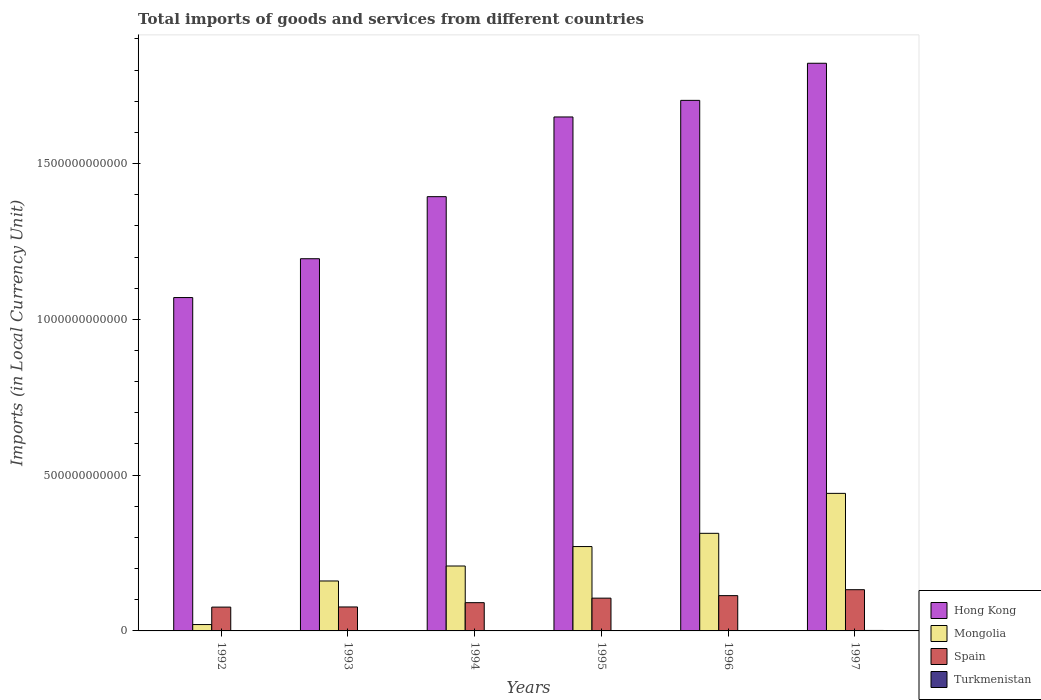How many groups of bars are there?
Offer a very short reply. 6. Are the number of bars per tick equal to the number of legend labels?
Provide a short and direct response. Yes. How many bars are there on the 1st tick from the left?
Give a very brief answer. 4. What is the label of the 4th group of bars from the left?
Offer a very short reply. 1995. In how many cases, is the number of bars for a given year not equal to the number of legend labels?
Your response must be concise. 0. What is the Amount of goods and services imports in Mongolia in 1993?
Your response must be concise. 1.60e+11. Across all years, what is the maximum Amount of goods and services imports in Hong Kong?
Offer a terse response. 1.82e+12. Across all years, what is the minimum Amount of goods and services imports in Mongolia?
Your answer should be very brief. 2.04e+1. In which year was the Amount of goods and services imports in Mongolia maximum?
Offer a terse response. 1997. What is the total Amount of goods and services imports in Spain in the graph?
Make the answer very short. 5.95e+11. What is the difference between the Amount of goods and services imports in Spain in 1993 and that in 1995?
Your answer should be very brief. -2.83e+1. What is the difference between the Amount of goods and services imports in Turkmenistan in 1992 and the Amount of goods and services imports in Spain in 1994?
Make the answer very short. -9.07e+1. What is the average Amount of goods and services imports in Turkmenistan per year?
Your answer should be compact. 4.70e+08. In the year 1995, what is the difference between the Amount of goods and services imports in Mongolia and Amount of goods and services imports in Spain?
Offer a very short reply. 1.66e+11. In how many years, is the Amount of goods and services imports in Turkmenistan greater than 1500000000000 LCU?
Ensure brevity in your answer.  0. What is the ratio of the Amount of goods and services imports in Turkmenistan in 1995 to that in 1996?
Keep it short and to the point. 0.09. What is the difference between the highest and the second highest Amount of goods and services imports in Turkmenistan?
Provide a succinct answer. 3.54e+08. What is the difference between the highest and the lowest Amount of goods and services imports in Mongolia?
Keep it short and to the point. 4.21e+11. In how many years, is the Amount of goods and services imports in Spain greater than the average Amount of goods and services imports in Spain taken over all years?
Your answer should be very brief. 3. What does the 3rd bar from the left in 1995 represents?
Your response must be concise. Spain. What does the 3rd bar from the right in 1994 represents?
Keep it short and to the point. Mongolia. Are all the bars in the graph horizontal?
Provide a short and direct response. No. What is the difference between two consecutive major ticks on the Y-axis?
Your response must be concise. 5.00e+11. Are the values on the major ticks of Y-axis written in scientific E-notation?
Provide a succinct answer. No. How many legend labels are there?
Provide a short and direct response. 4. What is the title of the graph?
Provide a short and direct response. Total imports of goods and services from different countries. Does "Belarus" appear as one of the legend labels in the graph?
Give a very brief answer. No. What is the label or title of the Y-axis?
Your answer should be very brief. Imports (in Local Currency Unit). What is the Imports (in Local Currency Unit) of Hong Kong in 1992?
Provide a short and direct response. 1.07e+12. What is the Imports (in Local Currency Unit) in Mongolia in 1992?
Offer a very short reply. 2.04e+1. What is the Imports (in Local Currency Unit) in Spain in 1992?
Your answer should be very brief. 7.65e+1. What is the Imports (in Local Currency Unit) in Turkmenistan in 1992?
Your answer should be compact. 6.11e+04. What is the Imports (in Local Currency Unit) in Hong Kong in 1993?
Keep it short and to the point. 1.19e+12. What is the Imports (in Local Currency Unit) in Mongolia in 1993?
Make the answer very short. 1.60e+11. What is the Imports (in Local Currency Unit) of Spain in 1993?
Keep it short and to the point. 7.69e+1. What is the Imports (in Local Currency Unit) of Turkmenistan in 1993?
Ensure brevity in your answer.  1.23e+06. What is the Imports (in Local Currency Unit) in Hong Kong in 1994?
Provide a succinct answer. 1.39e+12. What is the Imports (in Local Currency Unit) in Mongolia in 1994?
Offer a terse response. 2.08e+11. What is the Imports (in Local Currency Unit) of Spain in 1994?
Your answer should be very brief. 9.07e+1. What is the Imports (in Local Currency Unit) in Turkmenistan in 1994?
Provide a succinct answer. 1.49e+07. What is the Imports (in Local Currency Unit) in Hong Kong in 1995?
Your answer should be compact. 1.65e+12. What is the Imports (in Local Currency Unit) of Mongolia in 1995?
Make the answer very short. 2.71e+11. What is the Imports (in Local Currency Unit) in Spain in 1995?
Ensure brevity in your answer.  1.05e+11. What is the Imports (in Local Currency Unit) in Turkmenistan in 1995?
Offer a very short reply. 1.10e+08. What is the Imports (in Local Currency Unit) of Hong Kong in 1996?
Offer a terse response. 1.70e+12. What is the Imports (in Local Currency Unit) in Mongolia in 1996?
Keep it short and to the point. 3.13e+11. What is the Imports (in Local Currency Unit) in Spain in 1996?
Your answer should be compact. 1.13e+11. What is the Imports (in Local Currency Unit) in Turkmenistan in 1996?
Your answer should be very brief. 1.17e+09. What is the Imports (in Local Currency Unit) in Hong Kong in 1997?
Your answer should be very brief. 1.82e+12. What is the Imports (in Local Currency Unit) of Mongolia in 1997?
Make the answer very short. 4.42e+11. What is the Imports (in Local Currency Unit) in Spain in 1997?
Your answer should be very brief. 1.32e+11. What is the Imports (in Local Currency Unit) of Turkmenistan in 1997?
Keep it short and to the point. 1.52e+09. Across all years, what is the maximum Imports (in Local Currency Unit) of Hong Kong?
Provide a succinct answer. 1.82e+12. Across all years, what is the maximum Imports (in Local Currency Unit) in Mongolia?
Keep it short and to the point. 4.42e+11. Across all years, what is the maximum Imports (in Local Currency Unit) in Spain?
Your response must be concise. 1.32e+11. Across all years, what is the maximum Imports (in Local Currency Unit) in Turkmenistan?
Provide a succinct answer. 1.52e+09. Across all years, what is the minimum Imports (in Local Currency Unit) in Hong Kong?
Keep it short and to the point. 1.07e+12. Across all years, what is the minimum Imports (in Local Currency Unit) of Mongolia?
Provide a short and direct response. 2.04e+1. Across all years, what is the minimum Imports (in Local Currency Unit) of Spain?
Offer a terse response. 7.65e+1. Across all years, what is the minimum Imports (in Local Currency Unit) of Turkmenistan?
Offer a very short reply. 6.11e+04. What is the total Imports (in Local Currency Unit) of Hong Kong in the graph?
Ensure brevity in your answer.  8.83e+12. What is the total Imports (in Local Currency Unit) of Mongolia in the graph?
Offer a very short reply. 1.41e+12. What is the total Imports (in Local Currency Unit) in Spain in the graph?
Keep it short and to the point. 5.95e+11. What is the total Imports (in Local Currency Unit) in Turkmenistan in the graph?
Offer a very short reply. 2.82e+09. What is the difference between the Imports (in Local Currency Unit) of Hong Kong in 1992 and that in 1993?
Your response must be concise. -1.25e+11. What is the difference between the Imports (in Local Currency Unit) of Mongolia in 1992 and that in 1993?
Keep it short and to the point. -1.40e+11. What is the difference between the Imports (in Local Currency Unit) in Spain in 1992 and that in 1993?
Make the answer very short. -4.49e+08. What is the difference between the Imports (in Local Currency Unit) in Turkmenistan in 1992 and that in 1993?
Offer a very short reply. -1.17e+06. What is the difference between the Imports (in Local Currency Unit) in Hong Kong in 1992 and that in 1994?
Keep it short and to the point. -3.24e+11. What is the difference between the Imports (in Local Currency Unit) in Mongolia in 1992 and that in 1994?
Keep it short and to the point. -1.88e+11. What is the difference between the Imports (in Local Currency Unit) in Spain in 1992 and that in 1994?
Offer a terse response. -1.42e+1. What is the difference between the Imports (in Local Currency Unit) in Turkmenistan in 1992 and that in 1994?
Keep it short and to the point. -1.48e+07. What is the difference between the Imports (in Local Currency Unit) in Hong Kong in 1992 and that in 1995?
Your answer should be very brief. -5.80e+11. What is the difference between the Imports (in Local Currency Unit) of Mongolia in 1992 and that in 1995?
Offer a very short reply. -2.50e+11. What is the difference between the Imports (in Local Currency Unit) in Spain in 1992 and that in 1995?
Offer a very short reply. -2.87e+1. What is the difference between the Imports (in Local Currency Unit) of Turkmenistan in 1992 and that in 1995?
Make the answer very short. -1.10e+08. What is the difference between the Imports (in Local Currency Unit) in Hong Kong in 1992 and that in 1996?
Your answer should be compact. -6.33e+11. What is the difference between the Imports (in Local Currency Unit) of Mongolia in 1992 and that in 1996?
Ensure brevity in your answer.  -2.93e+11. What is the difference between the Imports (in Local Currency Unit) in Spain in 1992 and that in 1996?
Offer a terse response. -3.68e+1. What is the difference between the Imports (in Local Currency Unit) of Turkmenistan in 1992 and that in 1996?
Give a very brief answer. -1.17e+09. What is the difference between the Imports (in Local Currency Unit) in Hong Kong in 1992 and that in 1997?
Provide a succinct answer. -7.52e+11. What is the difference between the Imports (in Local Currency Unit) in Mongolia in 1992 and that in 1997?
Offer a terse response. -4.21e+11. What is the difference between the Imports (in Local Currency Unit) of Spain in 1992 and that in 1997?
Ensure brevity in your answer.  -5.59e+1. What is the difference between the Imports (in Local Currency Unit) in Turkmenistan in 1992 and that in 1997?
Your answer should be very brief. -1.52e+09. What is the difference between the Imports (in Local Currency Unit) of Hong Kong in 1993 and that in 1994?
Your answer should be compact. -1.99e+11. What is the difference between the Imports (in Local Currency Unit) in Mongolia in 1993 and that in 1994?
Your answer should be compact. -4.80e+1. What is the difference between the Imports (in Local Currency Unit) in Spain in 1993 and that in 1994?
Offer a terse response. -1.38e+1. What is the difference between the Imports (in Local Currency Unit) in Turkmenistan in 1993 and that in 1994?
Your response must be concise. -1.36e+07. What is the difference between the Imports (in Local Currency Unit) in Hong Kong in 1993 and that in 1995?
Offer a terse response. -4.55e+11. What is the difference between the Imports (in Local Currency Unit) of Mongolia in 1993 and that in 1995?
Provide a succinct answer. -1.10e+11. What is the difference between the Imports (in Local Currency Unit) of Spain in 1993 and that in 1995?
Keep it short and to the point. -2.83e+1. What is the difference between the Imports (in Local Currency Unit) in Turkmenistan in 1993 and that in 1995?
Your response must be concise. -1.09e+08. What is the difference between the Imports (in Local Currency Unit) in Hong Kong in 1993 and that in 1996?
Offer a very short reply. -5.08e+11. What is the difference between the Imports (in Local Currency Unit) of Mongolia in 1993 and that in 1996?
Provide a short and direct response. -1.53e+11. What is the difference between the Imports (in Local Currency Unit) of Spain in 1993 and that in 1996?
Make the answer very short. -3.64e+1. What is the difference between the Imports (in Local Currency Unit) in Turkmenistan in 1993 and that in 1996?
Your answer should be very brief. -1.17e+09. What is the difference between the Imports (in Local Currency Unit) of Hong Kong in 1993 and that in 1997?
Provide a short and direct response. -6.27e+11. What is the difference between the Imports (in Local Currency Unit) of Mongolia in 1993 and that in 1997?
Make the answer very short. -2.81e+11. What is the difference between the Imports (in Local Currency Unit) of Spain in 1993 and that in 1997?
Offer a terse response. -5.54e+1. What is the difference between the Imports (in Local Currency Unit) of Turkmenistan in 1993 and that in 1997?
Your response must be concise. -1.52e+09. What is the difference between the Imports (in Local Currency Unit) in Hong Kong in 1994 and that in 1995?
Provide a short and direct response. -2.56e+11. What is the difference between the Imports (in Local Currency Unit) in Mongolia in 1994 and that in 1995?
Keep it short and to the point. -6.24e+1. What is the difference between the Imports (in Local Currency Unit) of Spain in 1994 and that in 1995?
Provide a succinct answer. -1.45e+1. What is the difference between the Imports (in Local Currency Unit) of Turkmenistan in 1994 and that in 1995?
Make the answer very short. -9.49e+07. What is the difference between the Imports (in Local Currency Unit) of Hong Kong in 1994 and that in 1996?
Offer a terse response. -3.09e+11. What is the difference between the Imports (in Local Currency Unit) of Mongolia in 1994 and that in 1996?
Your answer should be very brief. -1.05e+11. What is the difference between the Imports (in Local Currency Unit) of Spain in 1994 and that in 1996?
Your answer should be very brief. -2.26e+1. What is the difference between the Imports (in Local Currency Unit) of Turkmenistan in 1994 and that in 1996?
Offer a terse response. -1.15e+09. What is the difference between the Imports (in Local Currency Unit) of Hong Kong in 1994 and that in 1997?
Your response must be concise. -4.28e+11. What is the difference between the Imports (in Local Currency Unit) of Mongolia in 1994 and that in 1997?
Your answer should be compact. -2.33e+11. What is the difference between the Imports (in Local Currency Unit) in Spain in 1994 and that in 1997?
Your answer should be compact. -4.16e+1. What is the difference between the Imports (in Local Currency Unit) of Turkmenistan in 1994 and that in 1997?
Ensure brevity in your answer.  -1.51e+09. What is the difference between the Imports (in Local Currency Unit) in Hong Kong in 1995 and that in 1996?
Keep it short and to the point. -5.33e+1. What is the difference between the Imports (in Local Currency Unit) of Mongolia in 1995 and that in 1996?
Offer a very short reply. -4.25e+1. What is the difference between the Imports (in Local Currency Unit) of Spain in 1995 and that in 1996?
Keep it short and to the point. -8.08e+09. What is the difference between the Imports (in Local Currency Unit) of Turkmenistan in 1995 and that in 1996?
Ensure brevity in your answer.  -1.06e+09. What is the difference between the Imports (in Local Currency Unit) in Hong Kong in 1995 and that in 1997?
Ensure brevity in your answer.  -1.72e+11. What is the difference between the Imports (in Local Currency Unit) of Mongolia in 1995 and that in 1997?
Offer a terse response. -1.71e+11. What is the difference between the Imports (in Local Currency Unit) of Spain in 1995 and that in 1997?
Provide a succinct answer. -2.71e+1. What is the difference between the Imports (in Local Currency Unit) of Turkmenistan in 1995 and that in 1997?
Provide a short and direct response. -1.41e+09. What is the difference between the Imports (in Local Currency Unit) in Hong Kong in 1996 and that in 1997?
Ensure brevity in your answer.  -1.19e+11. What is the difference between the Imports (in Local Currency Unit) of Mongolia in 1996 and that in 1997?
Ensure brevity in your answer.  -1.28e+11. What is the difference between the Imports (in Local Currency Unit) of Spain in 1996 and that in 1997?
Your answer should be very brief. -1.90e+1. What is the difference between the Imports (in Local Currency Unit) in Turkmenistan in 1996 and that in 1997?
Make the answer very short. -3.54e+08. What is the difference between the Imports (in Local Currency Unit) of Hong Kong in 1992 and the Imports (in Local Currency Unit) of Mongolia in 1993?
Keep it short and to the point. 9.10e+11. What is the difference between the Imports (in Local Currency Unit) of Hong Kong in 1992 and the Imports (in Local Currency Unit) of Spain in 1993?
Your answer should be compact. 9.93e+11. What is the difference between the Imports (in Local Currency Unit) of Hong Kong in 1992 and the Imports (in Local Currency Unit) of Turkmenistan in 1993?
Your answer should be compact. 1.07e+12. What is the difference between the Imports (in Local Currency Unit) of Mongolia in 1992 and the Imports (in Local Currency Unit) of Spain in 1993?
Make the answer very short. -5.65e+1. What is the difference between the Imports (in Local Currency Unit) in Mongolia in 1992 and the Imports (in Local Currency Unit) in Turkmenistan in 1993?
Keep it short and to the point. 2.04e+1. What is the difference between the Imports (in Local Currency Unit) of Spain in 1992 and the Imports (in Local Currency Unit) of Turkmenistan in 1993?
Your answer should be compact. 7.65e+1. What is the difference between the Imports (in Local Currency Unit) in Hong Kong in 1992 and the Imports (in Local Currency Unit) in Mongolia in 1994?
Offer a very short reply. 8.62e+11. What is the difference between the Imports (in Local Currency Unit) of Hong Kong in 1992 and the Imports (in Local Currency Unit) of Spain in 1994?
Provide a short and direct response. 9.79e+11. What is the difference between the Imports (in Local Currency Unit) in Hong Kong in 1992 and the Imports (in Local Currency Unit) in Turkmenistan in 1994?
Your answer should be compact. 1.07e+12. What is the difference between the Imports (in Local Currency Unit) of Mongolia in 1992 and the Imports (in Local Currency Unit) of Spain in 1994?
Your answer should be very brief. -7.03e+1. What is the difference between the Imports (in Local Currency Unit) of Mongolia in 1992 and the Imports (in Local Currency Unit) of Turkmenistan in 1994?
Your answer should be compact. 2.04e+1. What is the difference between the Imports (in Local Currency Unit) in Spain in 1992 and the Imports (in Local Currency Unit) in Turkmenistan in 1994?
Give a very brief answer. 7.64e+1. What is the difference between the Imports (in Local Currency Unit) of Hong Kong in 1992 and the Imports (in Local Currency Unit) of Mongolia in 1995?
Offer a terse response. 7.99e+11. What is the difference between the Imports (in Local Currency Unit) in Hong Kong in 1992 and the Imports (in Local Currency Unit) in Spain in 1995?
Provide a short and direct response. 9.65e+11. What is the difference between the Imports (in Local Currency Unit) of Hong Kong in 1992 and the Imports (in Local Currency Unit) of Turkmenistan in 1995?
Your response must be concise. 1.07e+12. What is the difference between the Imports (in Local Currency Unit) in Mongolia in 1992 and the Imports (in Local Currency Unit) in Spain in 1995?
Your answer should be compact. -8.48e+1. What is the difference between the Imports (in Local Currency Unit) of Mongolia in 1992 and the Imports (in Local Currency Unit) of Turkmenistan in 1995?
Your response must be concise. 2.03e+1. What is the difference between the Imports (in Local Currency Unit) in Spain in 1992 and the Imports (in Local Currency Unit) in Turkmenistan in 1995?
Offer a terse response. 7.63e+1. What is the difference between the Imports (in Local Currency Unit) of Hong Kong in 1992 and the Imports (in Local Currency Unit) of Mongolia in 1996?
Ensure brevity in your answer.  7.57e+11. What is the difference between the Imports (in Local Currency Unit) in Hong Kong in 1992 and the Imports (in Local Currency Unit) in Spain in 1996?
Ensure brevity in your answer.  9.57e+11. What is the difference between the Imports (in Local Currency Unit) in Hong Kong in 1992 and the Imports (in Local Currency Unit) in Turkmenistan in 1996?
Your response must be concise. 1.07e+12. What is the difference between the Imports (in Local Currency Unit) in Mongolia in 1992 and the Imports (in Local Currency Unit) in Spain in 1996?
Keep it short and to the point. -9.29e+1. What is the difference between the Imports (in Local Currency Unit) of Mongolia in 1992 and the Imports (in Local Currency Unit) of Turkmenistan in 1996?
Offer a terse response. 1.92e+1. What is the difference between the Imports (in Local Currency Unit) of Spain in 1992 and the Imports (in Local Currency Unit) of Turkmenistan in 1996?
Give a very brief answer. 7.53e+1. What is the difference between the Imports (in Local Currency Unit) in Hong Kong in 1992 and the Imports (in Local Currency Unit) in Mongolia in 1997?
Your response must be concise. 6.28e+11. What is the difference between the Imports (in Local Currency Unit) in Hong Kong in 1992 and the Imports (in Local Currency Unit) in Spain in 1997?
Offer a very short reply. 9.38e+11. What is the difference between the Imports (in Local Currency Unit) in Hong Kong in 1992 and the Imports (in Local Currency Unit) in Turkmenistan in 1997?
Make the answer very short. 1.07e+12. What is the difference between the Imports (in Local Currency Unit) in Mongolia in 1992 and the Imports (in Local Currency Unit) in Spain in 1997?
Provide a short and direct response. -1.12e+11. What is the difference between the Imports (in Local Currency Unit) of Mongolia in 1992 and the Imports (in Local Currency Unit) of Turkmenistan in 1997?
Provide a short and direct response. 1.89e+1. What is the difference between the Imports (in Local Currency Unit) in Spain in 1992 and the Imports (in Local Currency Unit) in Turkmenistan in 1997?
Provide a short and direct response. 7.49e+1. What is the difference between the Imports (in Local Currency Unit) in Hong Kong in 1993 and the Imports (in Local Currency Unit) in Mongolia in 1994?
Ensure brevity in your answer.  9.86e+11. What is the difference between the Imports (in Local Currency Unit) of Hong Kong in 1993 and the Imports (in Local Currency Unit) of Spain in 1994?
Keep it short and to the point. 1.10e+12. What is the difference between the Imports (in Local Currency Unit) in Hong Kong in 1993 and the Imports (in Local Currency Unit) in Turkmenistan in 1994?
Your response must be concise. 1.19e+12. What is the difference between the Imports (in Local Currency Unit) in Mongolia in 1993 and the Imports (in Local Currency Unit) in Spain in 1994?
Make the answer very short. 6.96e+1. What is the difference between the Imports (in Local Currency Unit) in Mongolia in 1993 and the Imports (in Local Currency Unit) in Turkmenistan in 1994?
Keep it short and to the point. 1.60e+11. What is the difference between the Imports (in Local Currency Unit) in Spain in 1993 and the Imports (in Local Currency Unit) in Turkmenistan in 1994?
Provide a succinct answer. 7.69e+1. What is the difference between the Imports (in Local Currency Unit) of Hong Kong in 1993 and the Imports (in Local Currency Unit) of Mongolia in 1995?
Make the answer very short. 9.24e+11. What is the difference between the Imports (in Local Currency Unit) of Hong Kong in 1993 and the Imports (in Local Currency Unit) of Spain in 1995?
Make the answer very short. 1.09e+12. What is the difference between the Imports (in Local Currency Unit) in Hong Kong in 1993 and the Imports (in Local Currency Unit) in Turkmenistan in 1995?
Your response must be concise. 1.19e+12. What is the difference between the Imports (in Local Currency Unit) in Mongolia in 1993 and the Imports (in Local Currency Unit) in Spain in 1995?
Provide a short and direct response. 5.51e+1. What is the difference between the Imports (in Local Currency Unit) of Mongolia in 1993 and the Imports (in Local Currency Unit) of Turkmenistan in 1995?
Provide a short and direct response. 1.60e+11. What is the difference between the Imports (in Local Currency Unit) of Spain in 1993 and the Imports (in Local Currency Unit) of Turkmenistan in 1995?
Ensure brevity in your answer.  7.68e+1. What is the difference between the Imports (in Local Currency Unit) of Hong Kong in 1993 and the Imports (in Local Currency Unit) of Mongolia in 1996?
Provide a succinct answer. 8.81e+11. What is the difference between the Imports (in Local Currency Unit) of Hong Kong in 1993 and the Imports (in Local Currency Unit) of Spain in 1996?
Your answer should be very brief. 1.08e+12. What is the difference between the Imports (in Local Currency Unit) of Hong Kong in 1993 and the Imports (in Local Currency Unit) of Turkmenistan in 1996?
Offer a very short reply. 1.19e+12. What is the difference between the Imports (in Local Currency Unit) of Mongolia in 1993 and the Imports (in Local Currency Unit) of Spain in 1996?
Provide a short and direct response. 4.70e+1. What is the difference between the Imports (in Local Currency Unit) in Mongolia in 1993 and the Imports (in Local Currency Unit) in Turkmenistan in 1996?
Your response must be concise. 1.59e+11. What is the difference between the Imports (in Local Currency Unit) in Spain in 1993 and the Imports (in Local Currency Unit) in Turkmenistan in 1996?
Your answer should be very brief. 7.57e+1. What is the difference between the Imports (in Local Currency Unit) in Hong Kong in 1993 and the Imports (in Local Currency Unit) in Mongolia in 1997?
Ensure brevity in your answer.  7.53e+11. What is the difference between the Imports (in Local Currency Unit) of Hong Kong in 1993 and the Imports (in Local Currency Unit) of Spain in 1997?
Your answer should be compact. 1.06e+12. What is the difference between the Imports (in Local Currency Unit) in Hong Kong in 1993 and the Imports (in Local Currency Unit) in Turkmenistan in 1997?
Provide a succinct answer. 1.19e+12. What is the difference between the Imports (in Local Currency Unit) in Mongolia in 1993 and the Imports (in Local Currency Unit) in Spain in 1997?
Your response must be concise. 2.80e+1. What is the difference between the Imports (in Local Currency Unit) in Mongolia in 1993 and the Imports (in Local Currency Unit) in Turkmenistan in 1997?
Provide a succinct answer. 1.59e+11. What is the difference between the Imports (in Local Currency Unit) of Spain in 1993 and the Imports (in Local Currency Unit) of Turkmenistan in 1997?
Your answer should be compact. 7.54e+1. What is the difference between the Imports (in Local Currency Unit) in Hong Kong in 1994 and the Imports (in Local Currency Unit) in Mongolia in 1995?
Your answer should be very brief. 1.12e+12. What is the difference between the Imports (in Local Currency Unit) of Hong Kong in 1994 and the Imports (in Local Currency Unit) of Spain in 1995?
Your response must be concise. 1.29e+12. What is the difference between the Imports (in Local Currency Unit) of Hong Kong in 1994 and the Imports (in Local Currency Unit) of Turkmenistan in 1995?
Your response must be concise. 1.39e+12. What is the difference between the Imports (in Local Currency Unit) in Mongolia in 1994 and the Imports (in Local Currency Unit) in Spain in 1995?
Ensure brevity in your answer.  1.03e+11. What is the difference between the Imports (in Local Currency Unit) of Mongolia in 1994 and the Imports (in Local Currency Unit) of Turkmenistan in 1995?
Ensure brevity in your answer.  2.08e+11. What is the difference between the Imports (in Local Currency Unit) of Spain in 1994 and the Imports (in Local Currency Unit) of Turkmenistan in 1995?
Your answer should be very brief. 9.06e+1. What is the difference between the Imports (in Local Currency Unit) of Hong Kong in 1994 and the Imports (in Local Currency Unit) of Mongolia in 1996?
Offer a very short reply. 1.08e+12. What is the difference between the Imports (in Local Currency Unit) of Hong Kong in 1994 and the Imports (in Local Currency Unit) of Spain in 1996?
Your response must be concise. 1.28e+12. What is the difference between the Imports (in Local Currency Unit) of Hong Kong in 1994 and the Imports (in Local Currency Unit) of Turkmenistan in 1996?
Keep it short and to the point. 1.39e+12. What is the difference between the Imports (in Local Currency Unit) of Mongolia in 1994 and the Imports (in Local Currency Unit) of Spain in 1996?
Offer a terse response. 9.51e+1. What is the difference between the Imports (in Local Currency Unit) in Mongolia in 1994 and the Imports (in Local Currency Unit) in Turkmenistan in 1996?
Your answer should be very brief. 2.07e+11. What is the difference between the Imports (in Local Currency Unit) in Spain in 1994 and the Imports (in Local Currency Unit) in Turkmenistan in 1996?
Make the answer very short. 8.95e+1. What is the difference between the Imports (in Local Currency Unit) in Hong Kong in 1994 and the Imports (in Local Currency Unit) in Mongolia in 1997?
Keep it short and to the point. 9.52e+11. What is the difference between the Imports (in Local Currency Unit) of Hong Kong in 1994 and the Imports (in Local Currency Unit) of Spain in 1997?
Make the answer very short. 1.26e+12. What is the difference between the Imports (in Local Currency Unit) of Hong Kong in 1994 and the Imports (in Local Currency Unit) of Turkmenistan in 1997?
Provide a short and direct response. 1.39e+12. What is the difference between the Imports (in Local Currency Unit) in Mongolia in 1994 and the Imports (in Local Currency Unit) in Spain in 1997?
Provide a short and direct response. 7.60e+1. What is the difference between the Imports (in Local Currency Unit) of Mongolia in 1994 and the Imports (in Local Currency Unit) of Turkmenistan in 1997?
Your answer should be compact. 2.07e+11. What is the difference between the Imports (in Local Currency Unit) of Spain in 1994 and the Imports (in Local Currency Unit) of Turkmenistan in 1997?
Provide a succinct answer. 8.92e+1. What is the difference between the Imports (in Local Currency Unit) of Hong Kong in 1995 and the Imports (in Local Currency Unit) of Mongolia in 1996?
Provide a short and direct response. 1.34e+12. What is the difference between the Imports (in Local Currency Unit) of Hong Kong in 1995 and the Imports (in Local Currency Unit) of Spain in 1996?
Your answer should be very brief. 1.54e+12. What is the difference between the Imports (in Local Currency Unit) in Hong Kong in 1995 and the Imports (in Local Currency Unit) in Turkmenistan in 1996?
Keep it short and to the point. 1.65e+12. What is the difference between the Imports (in Local Currency Unit) of Mongolia in 1995 and the Imports (in Local Currency Unit) of Spain in 1996?
Keep it short and to the point. 1.57e+11. What is the difference between the Imports (in Local Currency Unit) in Mongolia in 1995 and the Imports (in Local Currency Unit) in Turkmenistan in 1996?
Your response must be concise. 2.70e+11. What is the difference between the Imports (in Local Currency Unit) in Spain in 1995 and the Imports (in Local Currency Unit) in Turkmenistan in 1996?
Offer a terse response. 1.04e+11. What is the difference between the Imports (in Local Currency Unit) in Hong Kong in 1995 and the Imports (in Local Currency Unit) in Mongolia in 1997?
Offer a terse response. 1.21e+12. What is the difference between the Imports (in Local Currency Unit) in Hong Kong in 1995 and the Imports (in Local Currency Unit) in Spain in 1997?
Provide a short and direct response. 1.52e+12. What is the difference between the Imports (in Local Currency Unit) of Hong Kong in 1995 and the Imports (in Local Currency Unit) of Turkmenistan in 1997?
Your answer should be very brief. 1.65e+12. What is the difference between the Imports (in Local Currency Unit) in Mongolia in 1995 and the Imports (in Local Currency Unit) in Spain in 1997?
Give a very brief answer. 1.38e+11. What is the difference between the Imports (in Local Currency Unit) in Mongolia in 1995 and the Imports (in Local Currency Unit) in Turkmenistan in 1997?
Your response must be concise. 2.69e+11. What is the difference between the Imports (in Local Currency Unit) of Spain in 1995 and the Imports (in Local Currency Unit) of Turkmenistan in 1997?
Offer a terse response. 1.04e+11. What is the difference between the Imports (in Local Currency Unit) in Hong Kong in 1996 and the Imports (in Local Currency Unit) in Mongolia in 1997?
Offer a very short reply. 1.26e+12. What is the difference between the Imports (in Local Currency Unit) in Hong Kong in 1996 and the Imports (in Local Currency Unit) in Spain in 1997?
Offer a very short reply. 1.57e+12. What is the difference between the Imports (in Local Currency Unit) of Hong Kong in 1996 and the Imports (in Local Currency Unit) of Turkmenistan in 1997?
Provide a short and direct response. 1.70e+12. What is the difference between the Imports (in Local Currency Unit) in Mongolia in 1996 and the Imports (in Local Currency Unit) in Spain in 1997?
Give a very brief answer. 1.81e+11. What is the difference between the Imports (in Local Currency Unit) of Mongolia in 1996 and the Imports (in Local Currency Unit) of Turkmenistan in 1997?
Offer a very short reply. 3.12e+11. What is the difference between the Imports (in Local Currency Unit) in Spain in 1996 and the Imports (in Local Currency Unit) in Turkmenistan in 1997?
Give a very brief answer. 1.12e+11. What is the average Imports (in Local Currency Unit) in Hong Kong per year?
Your response must be concise. 1.47e+12. What is the average Imports (in Local Currency Unit) of Mongolia per year?
Give a very brief answer. 2.36e+11. What is the average Imports (in Local Currency Unit) in Spain per year?
Provide a succinct answer. 9.91e+1. What is the average Imports (in Local Currency Unit) in Turkmenistan per year?
Give a very brief answer. 4.70e+08. In the year 1992, what is the difference between the Imports (in Local Currency Unit) of Hong Kong and Imports (in Local Currency Unit) of Mongolia?
Offer a very short reply. 1.05e+12. In the year 1992, what is the difference between the Imports (in Local Currency Unit) in Hong Kong and Imports (in Local Currency Unit) in Spain?
Ensure brevity in your answer.  9.93e+11. In the year 1992, what is the difference between the Imports (in Local Currency Unit) in Hong Kong and Imports (in Local Currency Unit) in Turkmenistan?
Your answer should be very brief. 1.07e+12. In the year 1992, what is the difference between the Imports (in Local Currency Unit) of Mongolia and Imports (in Local Currency Unit) of Spain?
Keep it short and to the point. -5.60e+1. In the year 1992, what is the difference between the Imports (in Local Currency Unit) in Mongolia and Imports (in Local Currency Unit) in Turkmenistan?
Your answer should be compact. 2.04e+1. In the year 1992, what is the difference between the Imports (in Local Currency Unit) of Spain and Imports (in Local Currency Unit) of Turkmenistan?
Your answer should be compact. 7.65e+1. In the year 1993, what is the difference between the Imports (in Local Currency Unit) of Hong Kong and Imports (in Local Currency Unit) of Mongolia?
Offer a very short reply. 1.03e+12. In the year 1993, what is the difference between the Imports (in Local Currency Unit) in Hong Kong and Imports (in Local Currency Unit) in Spain?
Make the answer very short. 1.12e+12. In the year 1993, what is the difference between the Imports (in Local Currency Unit) in Hong Kong and Imports (in Local Currency Unit) in Turkmenistan?
Your answer should be very brief. 1.19e+12. In the year 1993, what is the difference between the Imports (in Local Currency Unit) in Mongolia and Imports (in Local Currency Unit) in Spain?
Offer a very short reply. 8.34e+1. In the year 1993, what is the difference between the Imports (in Local Currency Unit) of Mongolia and Imports (in Local Currency Unit) of Turkmenistan?
Offer a very short reply. 1.60e+11. In the year 1993, what is the difference between the Imports (in Local Currency Unit) in Spain and Imports (in Local Currency Unit) in Turkmenistan?
Give a very brief answer. 7.69e+1. In the year 1994, what is the difference between the Imports (in Local Currency Unit) in Hong Kong and Imports (in Local Currency Unit) in Mongolia?
Offer a terse response. 1.19e+12. In the year 1994, what is the difference between the Imports (in Local Currency Unit) in Hong Kong and Imports (in Local Currency Unit) in Spain?
Your answer should be compact. 1.30e+12. In the year 1994, what is the difference between the Imports (in Local Currency Unit) in Hong Kong and Imports (in Local Currency Unit) in Turkmenistan?
Keep it short and to the point. 1.39e+12. In the year 1994, what is the difference between the Imports (in Local Currency Unit) in Mongolia and Imports (in Local Currency Unit) in Spain?
Offer a very short reply. 1.18e+11. In the year 1994, what is the difference between the Imports (in Local Currency Unit) of Mongolia and Imports (in Local Currency Unit) of Turkmenistan?
Provide a short and direct response. 2.08e+11. In the year 1994, what is the difference between the Imports (in Local Currency Unit) of Spain and Imports (in Local Currency Unit) of Turkmenistan?
Offer a very short reply. 9.07e+1. In the year 1995, what is the difference between the Imports (in Local Currency Unit) in Hong Kong and Imports (in Local Currency Unit) in Mongolia?
Provide a short and direct response. 1.38e+12. In the year 1995, what is the difference between the Imports (in Local Currency Unit) of Hong Kong and Imports (in Local Currency Unit) of Spain?
Provide a short and direct response. 1.54e+12. In the year 1995, what is the difference between the Imports (in Local Currency Unit) of Hong Kong and Imports (in Local Currency Unit) of Turkmenistan?
Your response must be concise. 1.65e+12. In the year 1995, what is the difference between the Imports (in Local Currency Unit) in Mongolia and Imports (in Local Currency Unit) in Spain?
Provide a short and direct response. 1.66e+11. In the year 1995, what is the difference between the Imports (in Local Currency Unit) of Mongolia and Imports (in Local Currency Unit) of Turkmenistan?
Your answer should be very brief. 2.71e+11. In the year 1995, what is the difference between the Imports (in Local Currency Unit) of Spain and Imports (in Local Currency Unit) of Turkmenistan?
Keep it short and to the point. 1.05e+11. In the year 1996, what is the difference between the Imports (in Local Currency Unit) of Hong Kong and Imports (in Local Currency Unit) of Mongolia?
Offer a very short reply. 1.39e+12. In the year 1996, what is the difference between the Imports (in Local Currency Unit) in Hong Kong and Imports (in Local Currency Unit) in Spain?
Ensure brevity in your answer.  1.59e+12. In the year 1996, what is the difference between the Imports (in Local Currency Unit) of Hong Kong and Imports (in Local Currency Unit) of Turkmenistan?
Ensure brevity in your answer.  1.70e+12. In the year 1996, what is the difference between the Imports (in Local Currency Unit) of Mongolia and Imports (in Local Currency Unit) of Spain?
Make the answer very short. 2.00e+11. In the year 1996, what is the difference between the Imports (in Local Currency Unit) of Mongolia and Imports (in Local Currency Unit) of Turkmenistan?
Give a very brief answer. 3.12e+11. In the year 1996, what is the difference between the Imports (in Local Currency Unit) in Spain and Imports (in Local Currency Unit) in Turkmenistan?
Give a very brief answer. 1.12e+11. In the year 1997, what is the difference between the Imports (in Local Currency Unit) of Hong Kong and Imports (in Local Currency Unit) of Mongolia?
Provide a succinct answer. 1.38e+12. In the year 1997, what is the difference between the Imports (in Local Currency Unit) of Hong Kong and Imports (in Local Currency Unit) of Spain?
Offer a terse response. 1.69e+12. In the year 1997, what is the difference between the Imports (in Local Currency Unit) in Hong Kong and Imports (in Local Currency Unit) in Turkmenistan?
Keep it short and to the point. 1.82e+12. In the year 1997, what is the difference between the Imports (in Local Currency Unit) of Mongolia and Imports (in Local Currency Unit) of Spain?
Your answer should be compact. 3.09e+11. In the year 1997, what is the difference between the Imports (in Local Currency Unit) in Mongolia and Imports (in Local Currency Unit) in Turkmenistan?
Keep it short and to the point. 4.40e+11. In the year 1997, what is the difference between the Imports (in Local Currency Unit) of Spain and Imports (in Local Currency Unit) of Turkmenistan?
Your answer should be very brief. 1.31e+11. What is the ratio of the Imports (in Local Currency Unit) of Hong Kong in 1992 to that in 1993?
Ensure brevity in your answer.  0.9. What is the ratio of the Imports (in Local Currency Unit) of Mongolia in 1992 to that in 1993?
Provide a short and direct response. 0.13. What is the ratio of the Imports (in Local Currency Unit) in Spain in 1992 to that in 1993?
Make the answer very short. 0.99. What is the ratio of the Imports (in Local Currency Unit) of Turkmenistan in 1992 to that in 1993?
Your response must be concise. 0.05. What is the ratio of the Imports (in Local Currency Unit) of Hong Kong in 1992 to that in 1994?
Provide a succinct answer. 0.77. What is the ratio of the Imports (in Local Currency Unit) of Mongolia in 1992 to that in 1994?
Offer a very short reply. 0.1. What is the ratio of the Imports (in Local Currency Unit) in Spain in 1992 to that in 1994?
Offer a terse response. 0.84. What is the ratio of the Imports (in Local Currency Unit) in Turkmenistan in 1992 to that in 1994?
Make the answer very short. 0. What is the ratio of the Imports (in Local Currency Unit) in Hong Kong in 1992 to that in 1995?
Provide a short and direct response. 0.65. What is the ratio of the Imports (in Local Currency Unit) of Mongolia in 1992 to that in 1995?
Ensure brevity in your answer.  0.08. What is the ratio of the Imports (in Local Currency Unit) of Spain in 1992 to that in 1995?
Make the answer very short. 0.73. What is the ratio of the Imports (in Local Currency Unit) in Turkmenistan in 1992 to that in 1995?
Provide a short and direct response. 0. What is the ratio of the Imports (in Local Currency Unit) of Hong Kong in 1992 to that in 1996?
Provide a succinct answer. 0.63. What is the ratio of the Imports (in Local Currency Unit) of Mongolia in 1992 to that in 1996?
Your answer should be compact. 0.07. What is the ratio of the Imports (in Local Currency Unit) in Spain in 1992 to that in 1996?
Provide a succinct answer. 0.68. What is the ratio of the Imports (in Local Currency Unit) in Turkmenistan in 1992 to that in 1996?
Ensure brevity in your answer.  0. What is the ratio of the Imports (in Local Currency Unit) of Hong Kong in 1992 to that in 1997?
Give a very brief answer. 0.59. What is the ratio of the Imports (in Local Currency Unit) in Mongolia in 1992 to that in 1997?
Make the answer very short. 0.05. What is the ratio of the Imports (in Local Currency Unit) of Spain in 1992 to that in 1997?
Your response must be concise. 0.58. What is the ratio of the Imports (in Local Currency Unit) in Turkmenistan in 1992 to that in 1997?
Your response must be concise. 0. What is the ratio of the Imports (in Local Currency Unit) of Hong Kong in 1993 to that in 1994?
Ensure brevity in your answer.  0.86. What is the ratio of the Imports (in Local Currency Unit) of Mongolia in 1993 to that in 1994?
Your answer should be compact. 0.77. What is the ratio of the Imports (in Local Currency Unit) of Spain in 1993 to that in 1994?
Provide a short and direct response. 0.85. What is the ratio of the Imports (in Local Currency Unit) in Turkmenistan in 1993 to that in 1994?
Offer a very short reply. 0.08. What is the ratio of the Imports (in Local Currency Unit) in Hong Kong in 1993 to that in 1995?
Your answer should be very brief. 0.72. What is the ratio of the Imports (in Local Currency Unit) of Mongolia in 1993 to that in 1995?
Ensure brevity in your answer.  0.59. What is the ratio of the Imports (in Local Currency Unit) in Spain in 1993 to that in 1995?
Give a very brief answer. 0.73. What is the ratio of the Imports (in Local Currency Unit) in Turkmenistan in 1993 to that in 1995?
Ensure brevity in your answer.  0.01. What is the ratio of the Imports (in Local Currency Unit) of Hong Kong in 1993 to that in 1996?
Ensure brevity in your answer.  0.7. What is the ratio of the Imports (in Local Currency Unit) of Mongolia in 1993 to that in 1996?
Your answer should be compact. 0.51. What is the ratio of the Imports (in Local Currency Unit) in Spain in 1993 to that in 1996?
Offer a terse response. 0.68. What is the ratio of the Imports (in Local Currency Unit) of Turkmenistan in 1993 to that in 1996?
Your answer should be very brief. 0. What is the ratio of the Imports (in Local Currency Unit) of Hong Kong in 1993 to that in 1997?
Give a very brief answer. 0.66. What is the ratio of the Imports (in Local Currency Unit) in Mongolia in 1993 to that in 1997?
Ensure brevity in your answer.  0.36. What is the ratio of the Imports (in Local Currency Unit) in Spain in 1993 to that in 1997?
Your answer should be very brief. 0.58. What is the ratio of the Imports (in Local Currency Unit) of Turkmenistan in 1993 to that in 1997?
Provide a short and direct response. 0. What is the ratio of the Imports (in Local Currency Unit) of Hong Kong in 1994 to that in 1995?
Your response must be concise. 0.84. What is the ratio of the Imports (in Local Currency Unit) of Mongolia in 1994 to that in 1995?
Keep it short and to the point. 0.77. What is the ratio of the Imports (in Local Currency Unit) in Spain in 1994 to that in 1995?
Your answer should be compact. 0.86. What is the ratio of the Imports (in Local Currency Unit) in Turkmenistan in 1994 to that in 1995?
Keep it short and to the point. 0.14. What is the ratio of the Imports (in Local Currency Unit) of Hong Kong in 1994 to that in 1996?
Offer a very short reply. 0.82. What is the ratio of the Imports (in Local Currency Unit) of Mongolia in 1994 to that in 1996?
Provide a short and direct response. 0.67. What is the ratio of the Imports (in Local Currency Unit) of Spain in 1994 to that in 1996?
Your response must be concise. 0.8. What is the ratio of the Imports (in Local Currency Unit) of Turkmenistan in 1994 to that in 1996?
Your answer should be compact. 0.01. What is the ratio of the Imports (in Local Currency Unit) of Hong Kong in 1994 to that in 1997?
Ensure brevity in your answer.  0.77. What is the ratio of the Imports (in Local Currency Unit) in Mongolia in 1994 to that in 1997?
Ensure brevity in your answer.  0.47. What is the ratio of the Imports (in Local Currency Unit) in Spain in 1994 to that in 1997?
Ensure brevity in your answer.  0.69. What is the ratio of the Imports (in Local Currency Unit) in Turkmenistan in 1994 to that in 1997?
Offer a very short reply. 0.01. What is the ratio of the Imports (in Local Currency Unit) in Hong Kong in 1995 to that in 1996?
Provide a short and direct response. 0.97. What is the ratio of the Imports (in Local Currency Unit) of Mongolia in 1995 to that in 1996?
Your response must be concise. 0.86. What is the ratio of the Imports (in Local Currency Unit) of Turkmenistan in 1995 to that in 1996?
Your answer should be compact. 0.09. What is the ratio of the Imports (in Local Currency Unit) in Hong Kong in 1995 to that in 1997?
Make the answer very short. 0.91. What is the ratio of the Imports (in Local Currency Unit) of Mongolia in 1995 to that in 1997?
Provide a short and direct response. 0.61. What is the ratio of the Imports (in Local Currency Unit) of Spain in 1995 to that in 1997?
Offer a very short reply. 0.8. What is the ratio of the Imports (in Local Currency Unit) of Turkmenistan in 1995 to that in 1997?
Keep it short and to the point. 0.07. What is the ratio of the Imports (in Local Currency Unit) in Hong Kong in 1996 to that in 1997?
Keep it short and to the point. 0.93. What is the ratio of the Imports (in Local Currency Unit) of Mongolia in 1996 to that in 1997?
Make the answer very short. 0.71. What is the ratio of the Imports (in Local Currency Unit) of Spain in 1996 to that in 1997?
Your answer should be very brief. 0.86. What is the ratio of the Imports (in Local Currency Unit) of Turkmenistan in 1996 to that in 1997?
Keep it short and to the point. 0.77. What is the difference between the highest and the second highest Imports (in Local Currency Unit) in Hong Kong?
Provide a succinct answer. 1.19e+11. What is the difference between the highest and the second highest Imports (in Local Currency Unit) of Mongolia?
Make the answer very short. 1.28e+11. What is the difference between the highest and the second highest Imports (in Local Currency Unit) of Spain?
Make the answer very short. 1.90e+1. What is the difference between the highest and the second highest Imports (in Local Currency Unit) in Turkmenistan?
Make the answer very short. 3.54e+08. What is the difference between the highest and the lowest Imports (in Local Currency Unit) in Hong Kong?
Your response must be concise. 7.52e+11. What is the difference between the highest and the lowest Imports (in Local Currency Unit) in Mongolia?
Make the answer very short. 4.21e+11. What is the difference between the highest and the lowest Imports (in Local Currency Unit) of Spain?
Offer a terse response. 5.59e+1. What is the difference between the highest and the lowest Imports (in Local Currency Unit) of Turkmenistan?
Make the answer very short. 1.52e+09. 